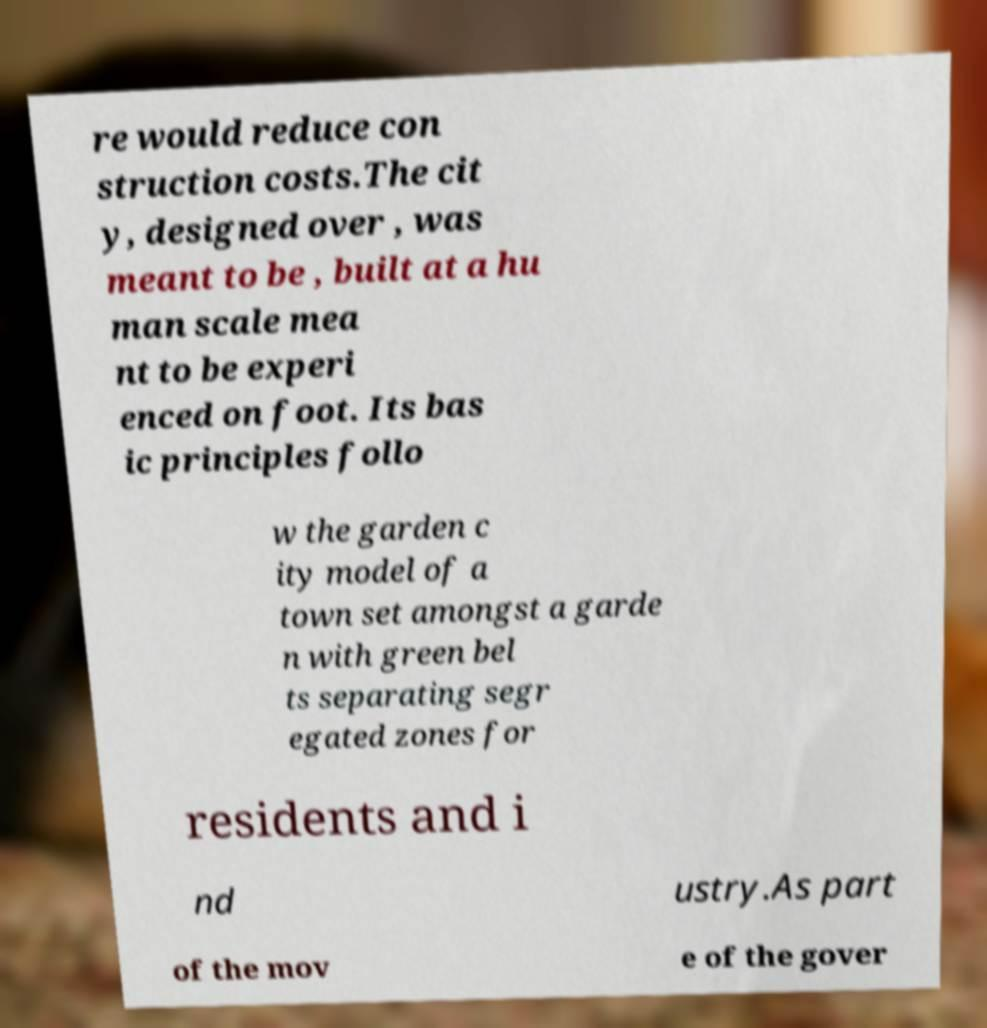Could you extract and type out the text from this image? re would reduce con struction costs.The cit y, designed over , was meant to be , built at a hu man scale mea nt to be experi enced on foot. Its bas ic principles follo w the garden c ity model of a town set amongst a garde n with green bel ts separating segr egated zones for residents and i nd ustry.As part of the mov e of the gover 